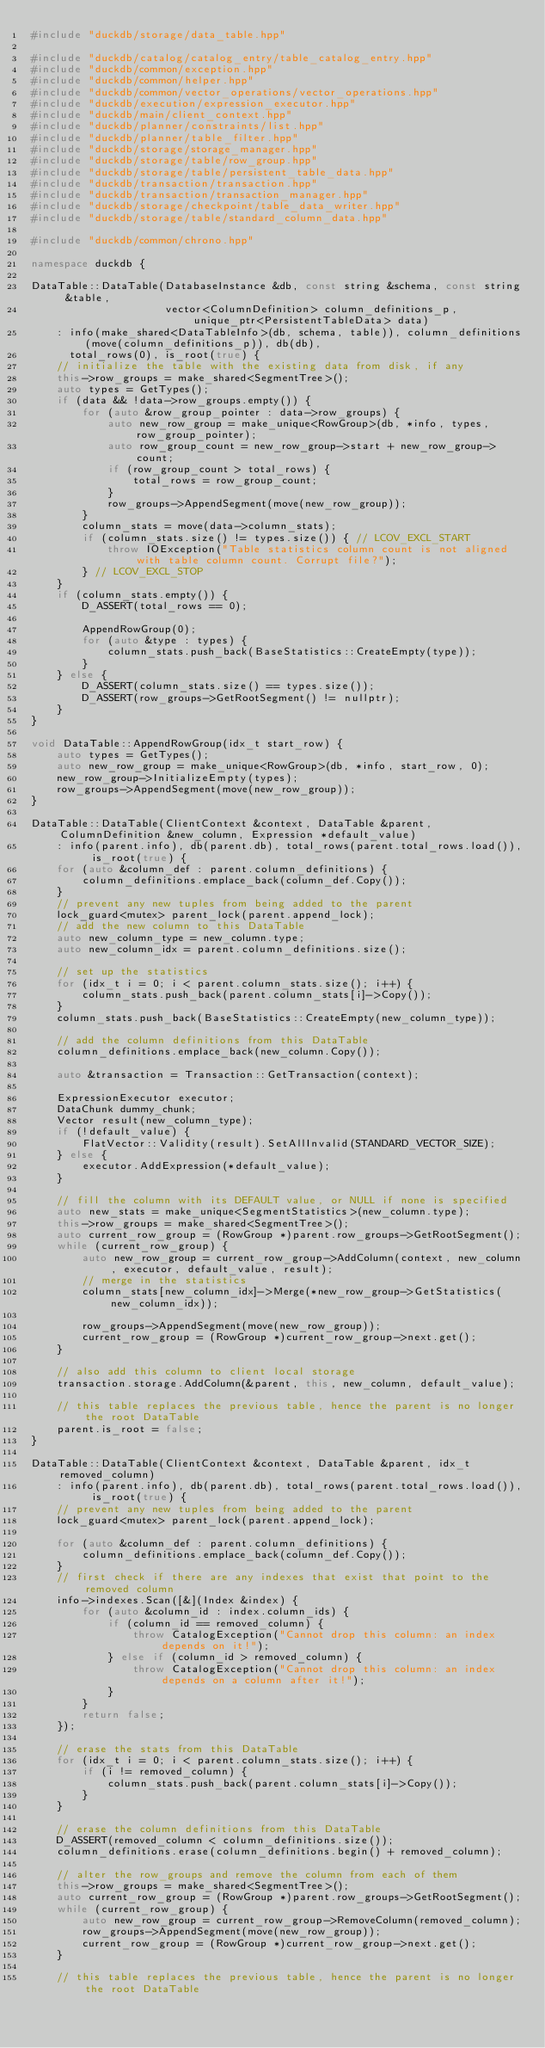Convert code to text. <code><loc_0><loc_0><loc_500><loc_500><_C++_>#include "duckdb/storage/data_table.hpp"

#include "duckdb/catalog/catalog_entry/table_catalog_entry.hpp"
#include "duckdb/common/exception.hpp"
#include "duckdb/common/helper.hpp"
#include "duckdb/common/vector_operations/vector_operations.hpp"
#include "duckdb/execution/expression_executor.hpp"
#include "duckdb/main/client_context.hpp"
#include "duckdb/planner/constraints/list.hpp"
#include "duckdb/planner/table_filter.hpp"
#include "duckdb/storage/storage_manager.hpp"
#include "duckdb/storage/table/row_group.hpp"
#include "duckdb/storage/table/persistent_table_data.hpp"
#include "duckdb/transaction/transaction.hpp"
#include "duckdb/transaction/transaction_manager.hpp"
#include "duckdb/storage/checkpoint/table_data_writer.hpp"
#include "duckdb/storage/table/standard_column_data.hpp"

#include "duckdb/common/chrono.hpp"

namespace duckdb {

DataTable::DataTable(DatabaseInstance &db, const string &schema, const string &table,
                     vector<ColumnDefinition> column_definitions_p, unique_ptr<PersistentTableData> data)
    : info(make_shared<DataTableInfo>(db, schema, table)), column_definitions(move(column_definitions_p)), db(db),
      total_rows(0), is_root(true) {
	// initialize the table with the existing data from disk, if any
	this->row_groups = make_shared<SegmentTree>();
	auto types = GetTypes();
	if (data && !data->row_groups.empty()) {
		for (auto &row_group_pointer : data->row_groups) {
			auto new_row_group = make_unique<RowGroup>(db, *info, types, row_group_pointer);
			auto row_group_count = new_row_group->start + new_row_group->count;
			if (row_group_count > total_rows) {
				total_rows = row_group_count;
			}
			row_groups->AppendSegment(move(new_row_group));
		}
		column_stats = move(data->column_stats);
		if (column_stats.size() != types.size()) { // LCOV_EXCL_START
			throw IOException("Table statistics column count is not aligned with table column count. Corrupt file?");
		} // LCOV_EXCL_STOP
	}
	if (column_stats.empty()) {
		D_ASSERT(total_rows == 0);

		AppendRowGroup(0);
		for (auto &type : types) {
			column_stats.push_back(BaseStatistics::CreateEmpty(type));
		}
	} else {
		D_ASSERT(column_stats.size() == types.size());
		D_ASSERT(row_groups->GetRootSegment() != nullptr);
	}
}

void DataTable::AppendRowGroup(idx_t start_row) {
	auto types = GetTypes();
	auto new_row_group = make_unique<RowGroup>(db, *info, start_row, 0);
	new_row_group->InitializeEmpty(types);
	row_groups->AppendSegment(move(new_row_group));
}

DataTable::DataTable(ClientContext &context, DataTable &parent, ColumnDefinition &new_column, Expression *default_value)
    : info(parent.info), db(parent.db), total_rows(parent.total_rows.load()), is_root(true) {
	for (auto &column_def : parent.column_definitions) {
		column_definitions.emplace_back(column_def.Copy());
	}
	// prevent any new tuples from being added to the parent
	lock_guard<mutex> parent_lock(parent.append_lock);
	// add the new column to this DataTable
	auto new_column_type = new_column.type;
	auto new_column_idx = parent.column_definitions.size();

	// set up the statistics
	for (idx_t i = 0; i < parent.column_stats.size(); i++) {
		column_stats.push_back(parent.column_stats[i]->Copy());
	}
	column_stats.push_back(BaseStatistics::CreateEmpty(new_column_type));

	// add the column definitions from this DataTable
	column_definitions.emplace_back(new_column.Copy());

	auto &transaction = Transaction::GetTransaction(context);

	ExpressionExecutor executor;
	DataChunk dummy_chunk;
	Vector result(new_column_type);
	if (!default_value) {
		FlatVector::Validity(result).SetAllInvalid(STANDARD_VECTOR_SIZE);
	} else {
		executor.AddExpression(*default_value);
	}

	// fill the column with its DEFAULT value, or NULL if none is specified
	auto new_stats = make_unique<SegmentStatistics>(new_column.type);
	this->row_groups = make_shared<SegmentTree>();
	auto current_row_group = (RowGroup *)parent.row_groups->GetRootSegment();
	while (current_row_group) {
		auto new_row_group = current_row_group->AddColumn(context, new_column, executor, default_value, result);
		// merge in the statistics
		column_stats[new_column_idx]->Merge(*new_row_group->GetStatistics(new_column_idx));

		row_groups->AppendSegment(move(new_row_group));
		current_row_group = (RowGroup *)current_row_group->next.get();
	}

	// also add this column to client local storage
	transaction.storage.AddColumn(&parent, this, new_column, default_value);

	// this table replaces the previous table, hence the parent is no longer the root DataTable
	parent.is_root = false;
}

DataTable::DataTable(ClientContext &context, DataTable &parent, idx_t removed_column)
    : info(parent.info), db(parent.db), total_rows(parent.total_rows.load()), is_root(true) {
	// prevent any new tuples from being added to the parent
	lock_guard<mutex> parent_lock(parent.append_lock);

	for (auto &column_def : parent.column_definitions) {
		column_definitions.emplace_back(column_def.Copy());
	}
	// first check if there are any indexes that exist that point to the removed column
	info->indexes.Scan([&](Index &index) {
		for (auto &column_id : index.column_ids) {
			if (column_id == removed_column) {
				throw CatalogException("Cannot drop this column: an index depends on it!");
			} else if (column_id > removed_column) {
				throw CatalogException("Cannot drop this column: an index depends on a column after it!");
			}
		}
		return false;
	});

	// erase the stats from this DataTable
	for (idx_t i = 0; i < parent.column_stats.size(); i++) {
		if (i != removed_column) {
			column_stats.push_back(parent.column_stats[i]->Copy());
		}
	}

	// erase the column definitions from this DataTable
	D_ASSERT(removed_column < column_definitions.size());
	column_definitions.erase(column_definitions.begin() + removed_column);

	// alter the row_groups and remove the column from each of them
	this->row_groups = make_shared<SegmentTree>();
	auto current_row_group = (RowGroup *)parent.row_groups->GetRootSegment();
	while (current_row_group) {
		auto new_row_group = current_row_group->RemoveColumn(removed_column);
		row_groups->AppendSegment(move(new_row_group));
		current_row_group = (RowGroup *)current_row_group->next.get();
	}

	// this table replaces the previous table, hence the parent is no longer the root DataTable</code> 